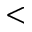<formula> <loc_0><loc_0><loc_500><loc_500><</formula> 